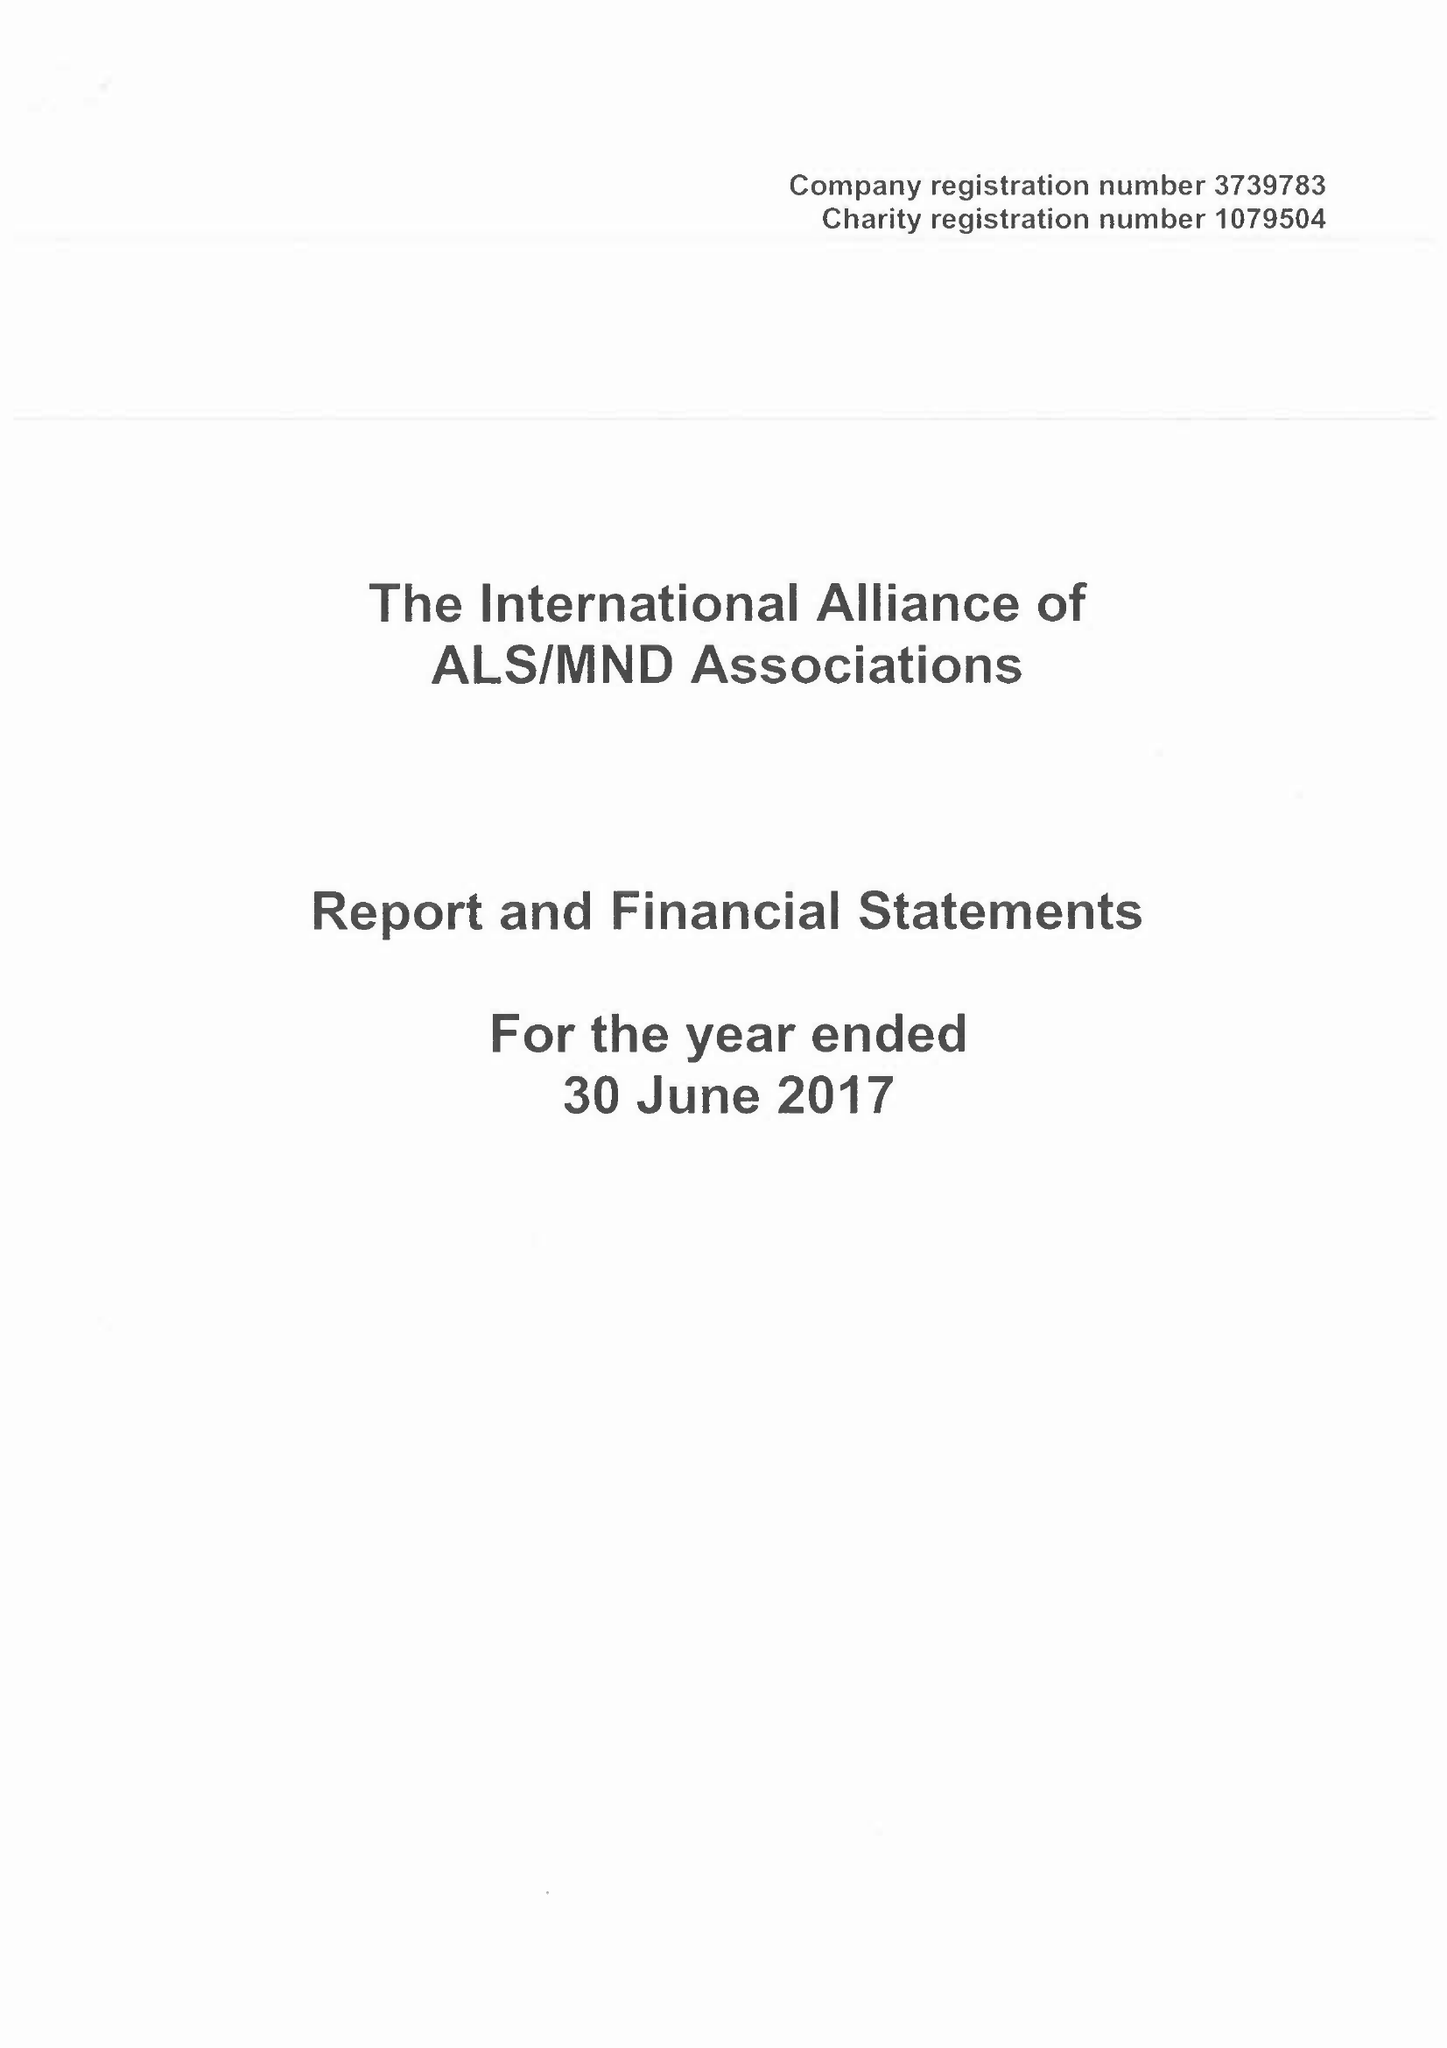What is the value for the charity_name?
Answer the question using a single word or phrase. The International Alliance Of Als / Mnd Associations 